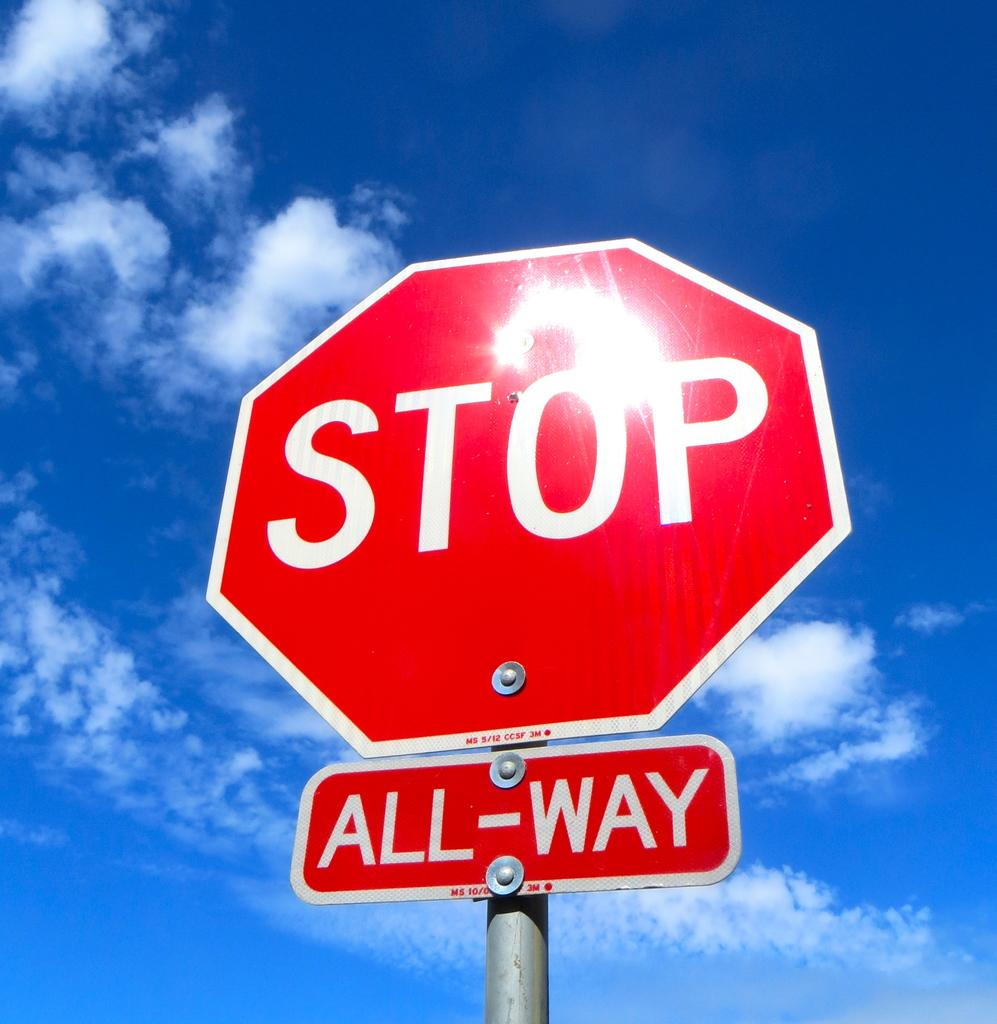What is attached to the pole in the image? There are boards on a pole in the image. What is written or depicted on the boards? There is text on the boards. What can be seen at the top of the image? The sky is visible at the top of the image. What is the condition of the sky in the image? There are clouds in the sky. Can you tell me how many lead chairs are depicted in the image? There is no lead or chair present in the image. What type of brush is used to create the text on the boards? There is no brush visible in the image, and the method of creating the text is not mentioned. 